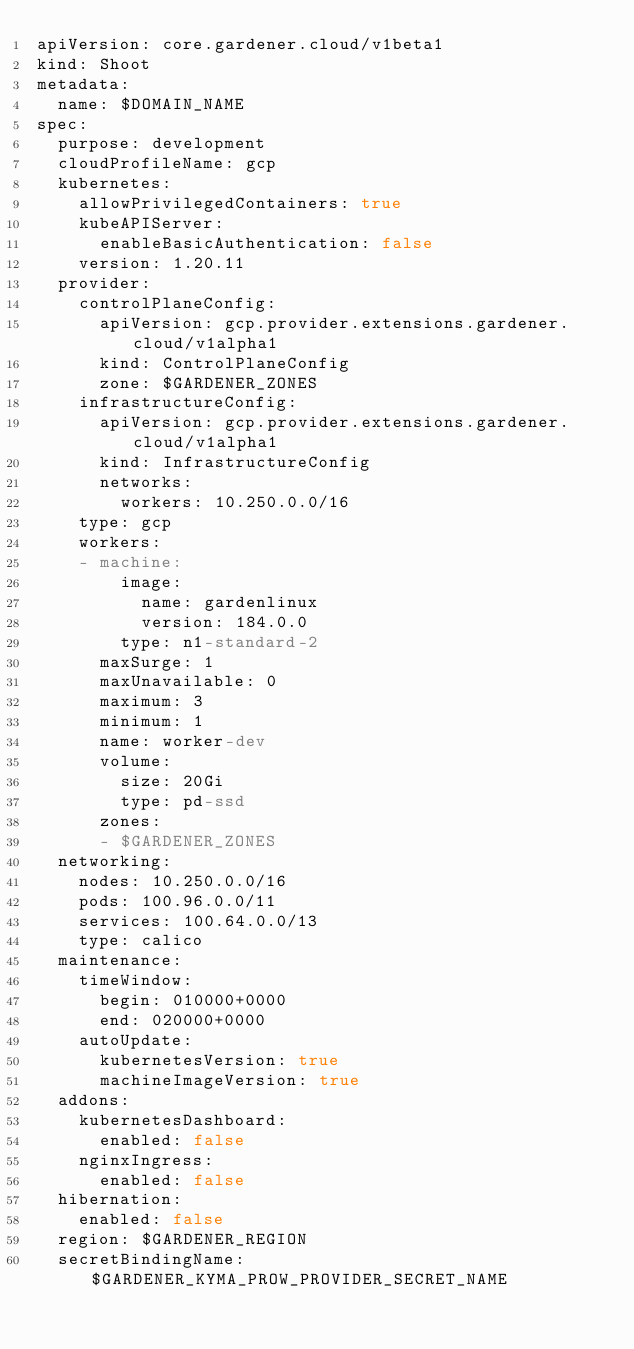Convert code to text. <code><loc_0><loc_0><loc_500><loc_500><_YAML_>apiVersion: core.gardener.cloud/v1beta1
kind: Shoot
metadata:
  name: $DOMAIN_NAME
spec:
  purpose: development
  cloudProfileName: gcp
  kubernetes:
    allowPrivilegedContainers: true
    kubeAPIServer:
      enableBasicAuthentication: false
    version: 1.20.11
  provider:
    controlPlaneConfig:
      apiVersion: gcp.provider.extensions.gardener.cloud/v1alpha1
      kind: ControlPlaneConfig
      zone: $GARDENER_ZONES
    infrastructureConfig:
      apiVersion: gcp.provider.extensions.gardener.cloud/v1alpha1
      kind: InfrastructureConfig
      networks:
        workers: 10.250.0.0/16
    type: gcp
    workers:
    - machine:
        image:
          name: gardenlinux
          version: 184.0.0
        type: n1-standard-2
      maxSurge: 1
      maxUnavailable: 0
      maximum: 3
      minimum: 1
      name: worker-dev
      volume:
        size: 20Gi
        type: pd-ssd
      zones:
      - $GARDENER_ZONES
  networking:
    nodes: 10.250.0.0/16
    pods: 100.96.0.0/11
    services: 100.64.0.0/13
    type: calico      
  maintenance:
    timeWindow:
      begin: 010000+0000
      end: 020000+0000
    autoUpdate:
      kubernetesVersion: true
      machineImageVersion: true
  addons:
    kubernetesDashboard:
      enabled: false
    nginxIngress:
      enabled: false      
  hibernation:
    enabled: false        
  region: $GARDENER_REGION
  secretBindingName: $GARDENER_KYMA_PROW_PROVIDER_SECRET_NAME
</code> 